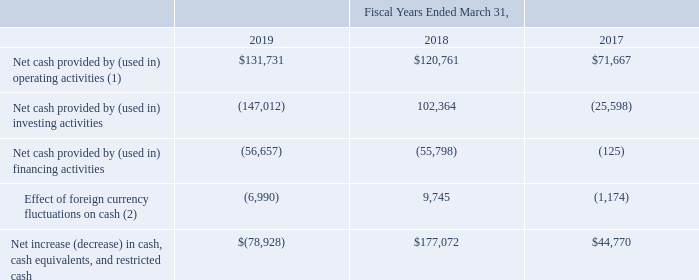Cash and cash equivalents decreased by $78.9 million during the year ended March 31, 2019, as compared to an increase of $177.1 million during the year ended March 31, 2018 and an increase of $44.8 million during the year ended March 31, 2017 as follows (amounts in thousands):
(1) Fiscal years ended March 31, 2018 and 2017 adjusted due to the adoption of ASC 606.
(2) Fiscal year ended March 31, 2018 adjusted due to the adoption of ASC 606.
Operating Cash Flow Activities
During fiscal years 2019, 2018, and 2017, cash provided by operating activities totaled $131.7 million, $120.8 million, and $71.7 million, respectively. During fiscal year 2019, cash provided by operating activities was positively impacted by our net income of $206.6 million, a $7.7 million increase in accounts payable, and a $1.0 million decrease in accrued income taxes. Operating cash flows were negatively impacted by a $70.6 million decrease in other operating liabilities, a $42.8 million increase in inventories, an $8.9 million increase in accounts receivable, and a $4.4 million increase in prepaid expenses and other assets. The decrease in other operating liabilities was driven by a $46.3 million decrease in accruals for TOKIN anti-trust fines and a $7.8 million decrease in restructuring liabilities. The increase in inventory is due to increased customer demand.
During fiscal year 2018, cash provided by operating activities was positively impacted by our net income of $254.1 million. Excluding the acquired balances from TOKIN, operating cash flows were also positively impacted by a $30.2 million decrease in accounts receivable, a $4.3 million decrease in prepaid expenses and other assets, and a $1.3 million increase in accrued income taxes. Excluding the acquired balances from TOKIN, operating cash flows were negatively impacted by a $16.1 million decrease in accounts payable and a $13.8 million increase in inventories.
During fiscal year 2017, cash provided by operating activities was positively impacted by our net income of $47.2 million, a $16.8 million decrease in inventories, a $6.2 million increase in accounts payable, and a $1.7 million increase in other operating liabilities. Operating cash flows were negatively impacted by a $2.6 million increase in accounts receivable and a $1.8 million increase in prepaid expenses and other assets.
Investing Cash Flow Activities
During fiscal years 2019, 2018, and 2017, cash provided by (used in) investing activities totaled $(147.0) million, $102.4 million, and $(25.6) million, respectively. During fiscal year 2019, cash used in investing activities included capital expenditures of $146.1 million, primarily related to expanding capacity at our manufacturing facilities in Mexico, Portugal, China, Thailand and Japan, as well as information technology projects in the United States and Mexico. $16.3 million of the $146.1 million in capital expenditures were related to the Customer Capacity Agreements. Additionally, the Company invested $4.0 million in the form of capital contributions to KEMET Jianghai and Novasentis. Offsetting these uses of cash, we had asset sales of $2.3 million and received dividends of $0.8 million.
During fiscal year 2018, cash provided by investing activities was primarily due to $164.0 million in net cash received attributable to the bargain purchase of TOKIN. Additionally, we had proceeds from asset sales of $3.6 million and received dividends of $2.7 million. This was partially offset by capital expenditures of $65.0 million, primarily related to expanding capacity at our manufacturing facilities in Mexico, Portugal, China, Thailand and Japan, as well as for information technology projects in the United States and Mexico. In addition, the Company invested $3.0 million in the form of capital contributions to Novasentis.
During fiscal year 2017, cash used in investing activities was primarily due to capital expenditures of $25.6 million, primarily related to expanding capacity at our manufacturing facilities in Mexico, Italy, Portugal, and China.
Financing Cash Flow Activities
During fiscal years 2019, 2018, and 2017, cash used in financing activities totaled $56.7 million, $55.8 million, and $0.1 million, respectively. During fiscal year 2019, the Company received $281.8 million in proceeds from the TOKIN Term Loan Facility, net of discount, bank issuance costs, and other indirect issuance costs, $13.4 million in proceeds from advances from customers, as described in the earlier section titled "Customer Advances", received proceeds on an interest free loan from the Portuguese Government of $1.1 million, and received $0.5 million in cash proceeds from the exercise of stock options. The Company made $344.5 million in payments on long term debt, including two quarterly principal payments on the Term Loan Credit Agreement of $4.3 million, for a total of $8.6 million, $323.4 million to repay the remaining balance on the Term Loan Credit Agreement, and one principal payment on the TOKIN Term Loan Facility of $12.4 million. An early payment premium on the Term Loan Credit Agreement used $3.2 million in cash. Lastly, the Company paid two quarterly cash dividends for a total of $5.8 million.
During fiscal year 2018, cash used in financing activities was impacted by the following payments: (i) $353.0 million to pay off the remaining outstanding balance of the 10.5% Senior Notes, (ii) $33.9 million to repay the remaining outstanding balance of the revolving line of credit, and (iii) three quarterly principal payments on the Term Loan Credit Agreement for $4.3 million each, for a total of $12.9 million. The Company received $329.7 million in proceeds from the Term Loan Credit Agreement, net of discount, bank issuance costs, and other indirect issuance costs, received proceeds from the exercise of stock warrants and stock options for $8.8 million and $5.2 million, respectively, and received $0.3 million in proceeds on an interest free loan from the Portuguese Government.
During fiscal year 2017, the Company made $0.1 million in net payments on long-term debt, had cash outflows of $1.1 million for the purchase of treasury stock, and received $1.1 million from the exercise of stock options.
Which years does the table provide information for the cash and cash equivalents for the company?  2019, 2018, 2017. What was the Net cash provided by (used in) investing activities in 2018?
Answer scale should be: thousand. 102,364. What was the Net cash provided by (used in) financing activities in 2017?
Answer scale should be: thousand. (125). Which years did Net cash provided by operating activities exceed $100,000 thousand? (2019:131,731),(2018:120,761)
Answer: 2019, 2018. What was the change in Net cash provided by financing activities between 2017 and 2018?
Answer scale should be: thousand. -55,798-(-125)
Answer: -55673. What was the percentage change in the Net increase in cash, cash equivalents, and restricted cash between 2018 and 2019?
Answer scale should be: percent. (-78,928-177,072)/177,072
Answer: -144.57. 